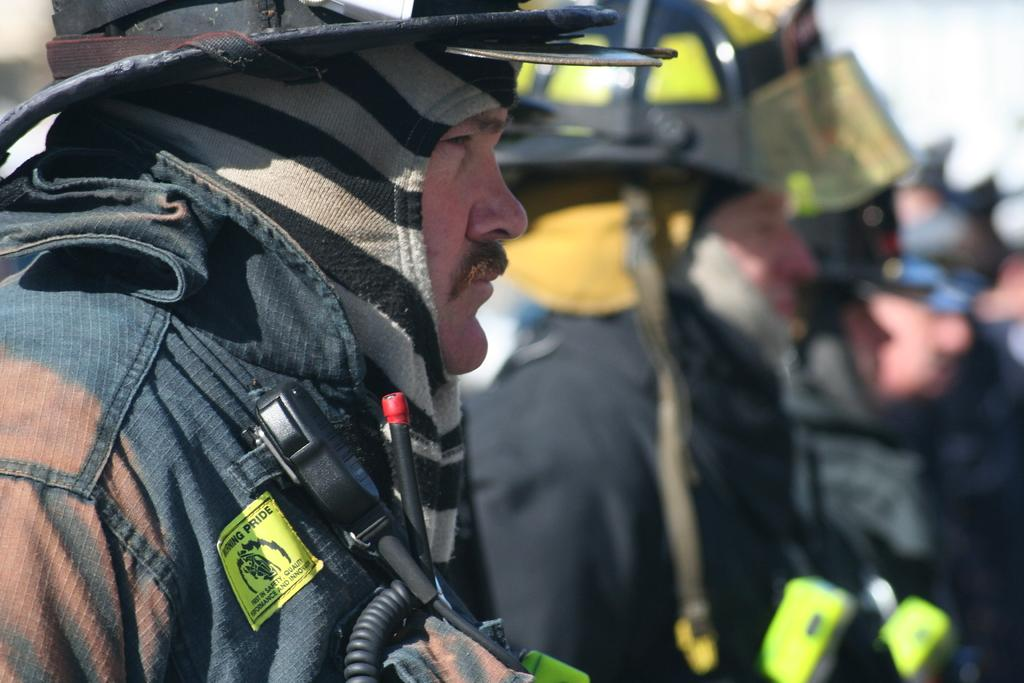What is the main subject in the foreground of the picture? There is a soldier standing in the foreground of the picture. How would you describe the background of the image? The background of the image is blurred. Can you see any other people in the image besides the soldier? Yes, there are people visible in the background of the image. How many frogs can be seen hopping on the grass in the image? There are no frogs or grass present in the image; it features a soldier standing in the foreground and a blurred background. 